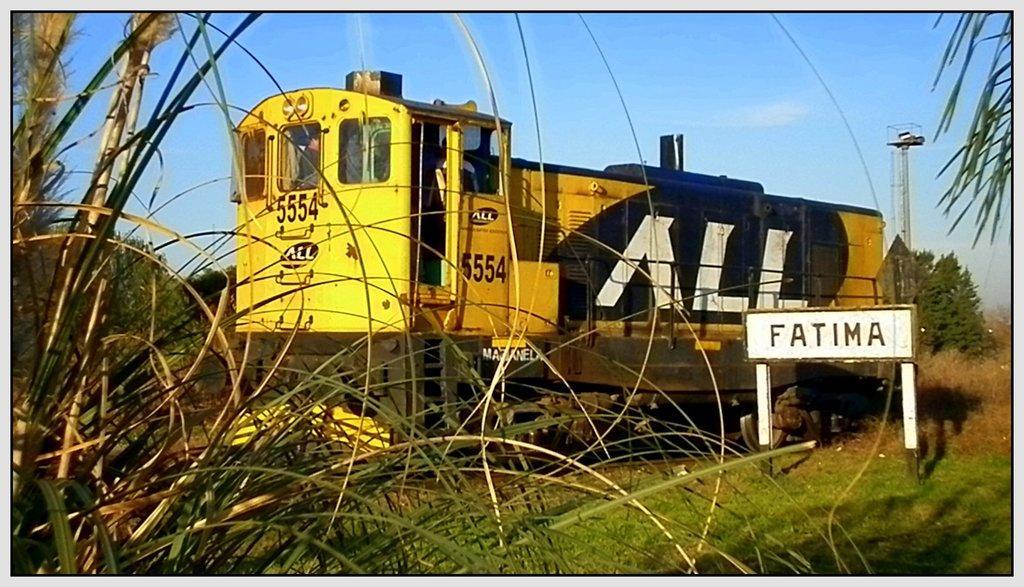In one or two sentences, can you explain what this image depicts? There is a yellow color engine with some numbers on that. There is a door and windows for that. Near to that there is a board with something written on that. On the left side there are plants and trees. In the back there are trees. And on the ground there are grasses. In the background there is sky. 